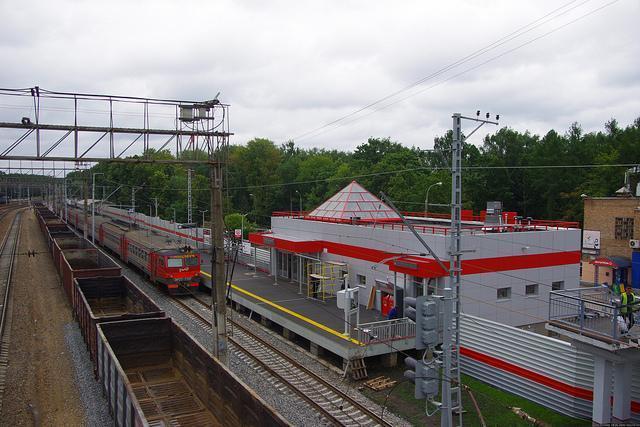How many train tracks are there?
Give a very brief answer. 1. How many zebras are in the picture?
Give a very brief answer. 0. 